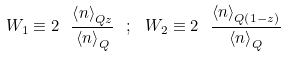Convert formula to latex. <formula><loc_0><loc_0><loc_500><loc_500>W _ { 1 } \equiv 2 \ \frac { \left \langle n \right \rangle _ { Q z } } { \left \langle n \right \rangle _ { Q } } \ ; \ W _ { 2 } \equiv 2 \ \frac { \left \langle n \right \rangle _ { Q \left ( 1 - z \right ) } } { \left \langle n \right \rangle _ { Q } }</formula> 